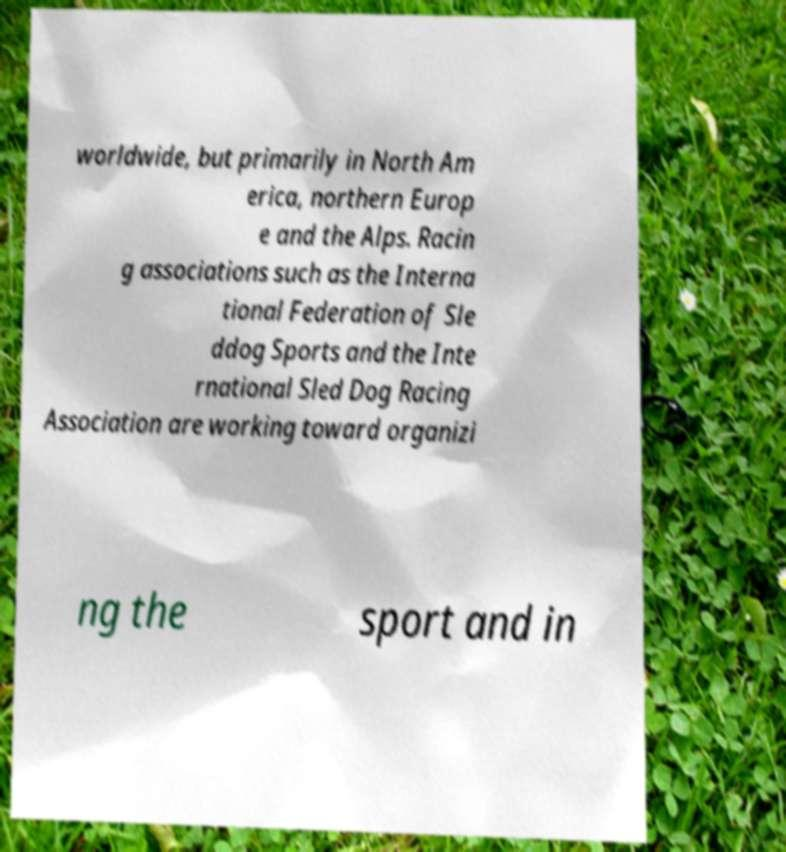Please read and relay the text visible in this image. What does it say? worldwide, but primarily in North Am erica, northern Europ e and the Alps. Racin g associations such as the Interna tional Federation of Sle ddog Sports and the Inte rnational Sled Dog Racing Association are working toward organizi ng the sport and in 